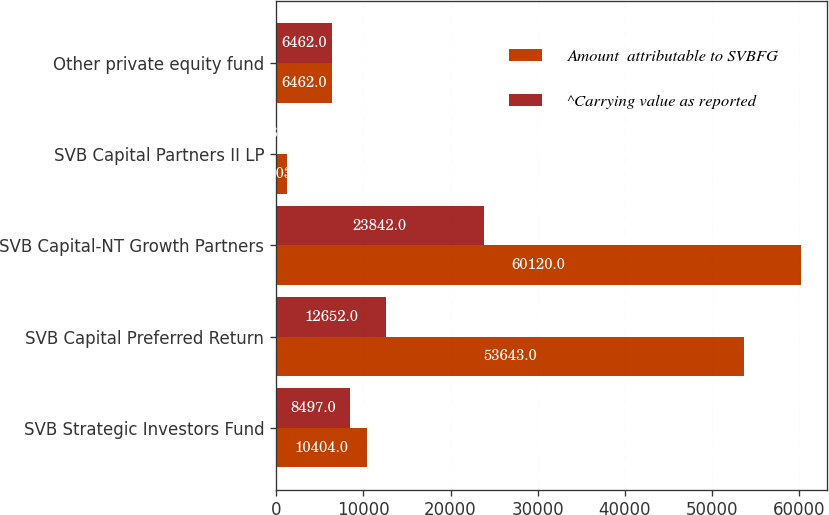Convert chart. <chart><loc_0><loc_0><loc_500><loc_500><stacked_bar_chart><ecel><fcel>SVB Strategic Investors Fund<fcel>SVB Capital Preferred Return<fcel>SVB Capital-NT Growth Partners<fcel>SVB Capital Partners II LP<fcel>Other private equity fund<nl><fcel>Amount  attributable to SVBFG<fcel>10404<fcel>53643<fcel>60120<fcel>1303<fcel>6462<nl><fcel>^Carrying value as reported<fcel>8497<fcel>12652<fcel>23842<fcel>66<fcel>6462<nl></chart> 